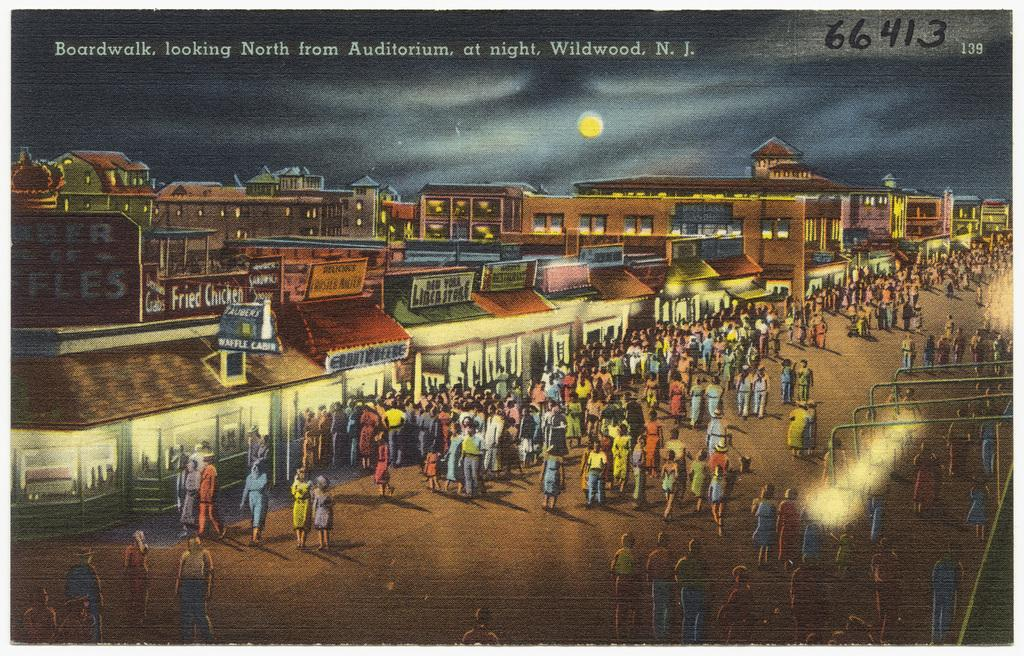Provide a one-sentence caption for the provided image. many people walking around and 66413 in the upper right. 